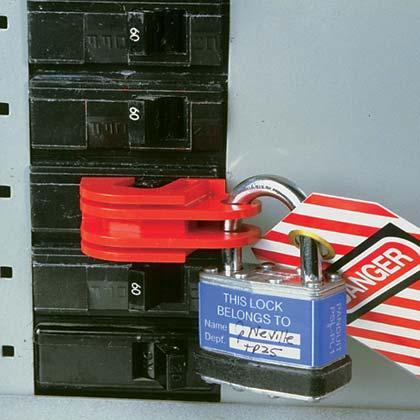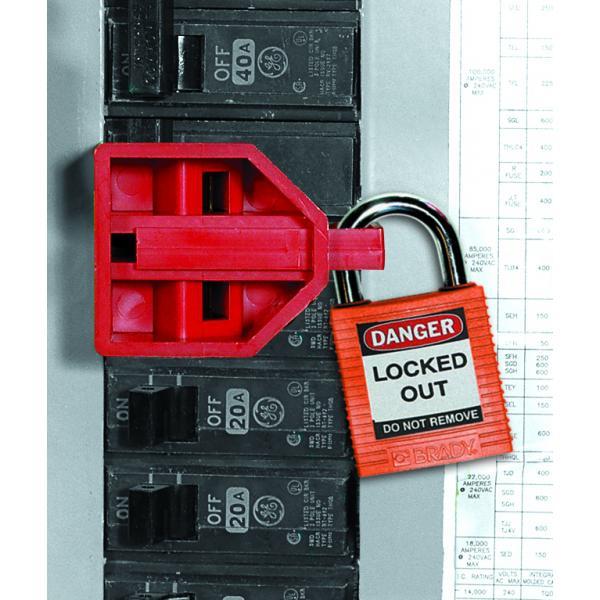The first image is the image on the left, the second image is the image on the right. For the images displayed, is the sentence "Red and white stripes are visible in one of the images." factually correct? Answer yes or no. Yes. 